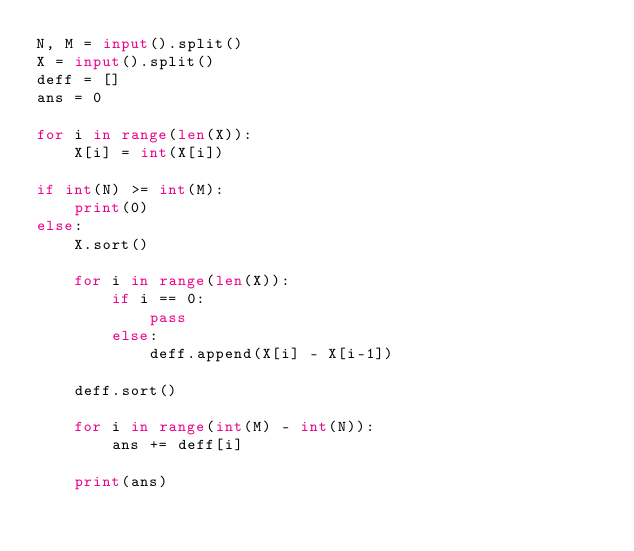Convert code to text. <code><loc_0><loc_0><loc_500><loc_500><_Python_>N, M = input().split()
X = input().split()
deff = []
ans = 0

for i in range(len(X)):
    X[i] = int(X[i])

if int(N) >= int(M):
    print(0)
else:
    X.sort()

    for i in range(len(X)):
        if i == 0:
            pass
        else:
            deff.append(X[i] - X[i-1])

    deff.sort()

    for i in range(int(M) - int(N)):
        ans += deff[i]

    print(ans)</code> 